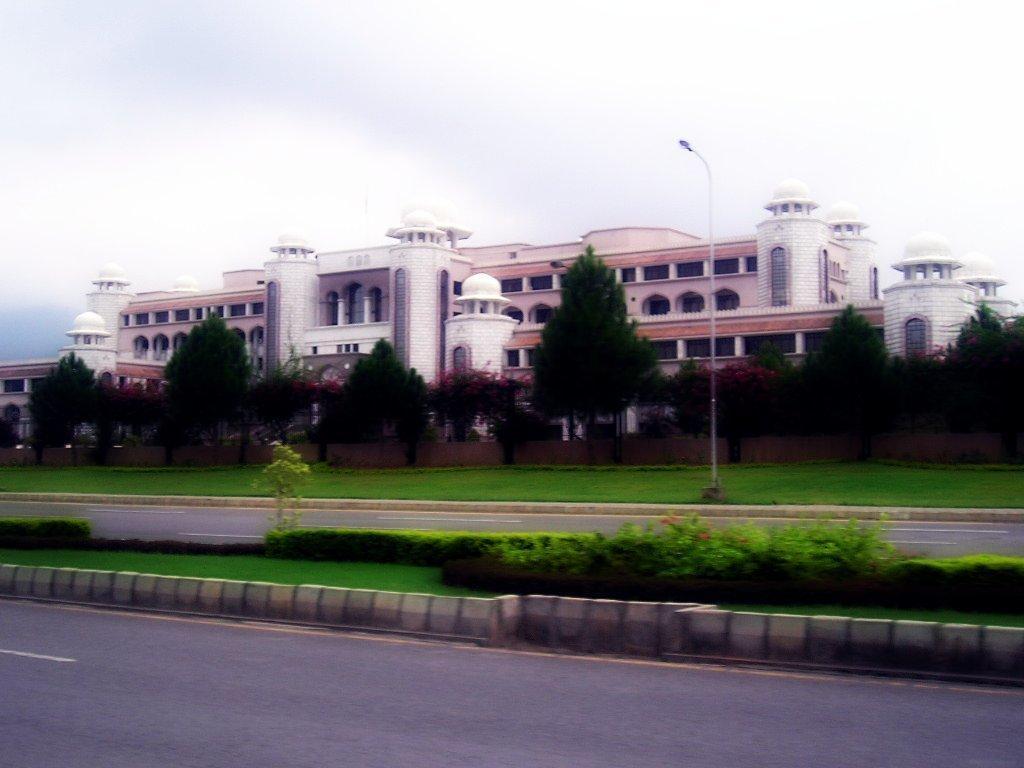Could you give a brief overview of what you see in this image? This is a blur image of a building I can see trees and a light pole and a road in the center of the image and a divider and another road at the bottom of the image and at the top of the image I can see the sky.  